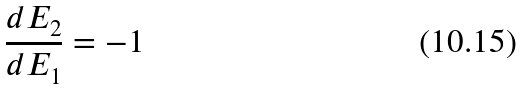Convert formula to latex. <formula><loc_0><loc_0><loc_500><loc_500>\frac { d E _ { 2 } } { d E _ { 1 } } = - 1</formula> 